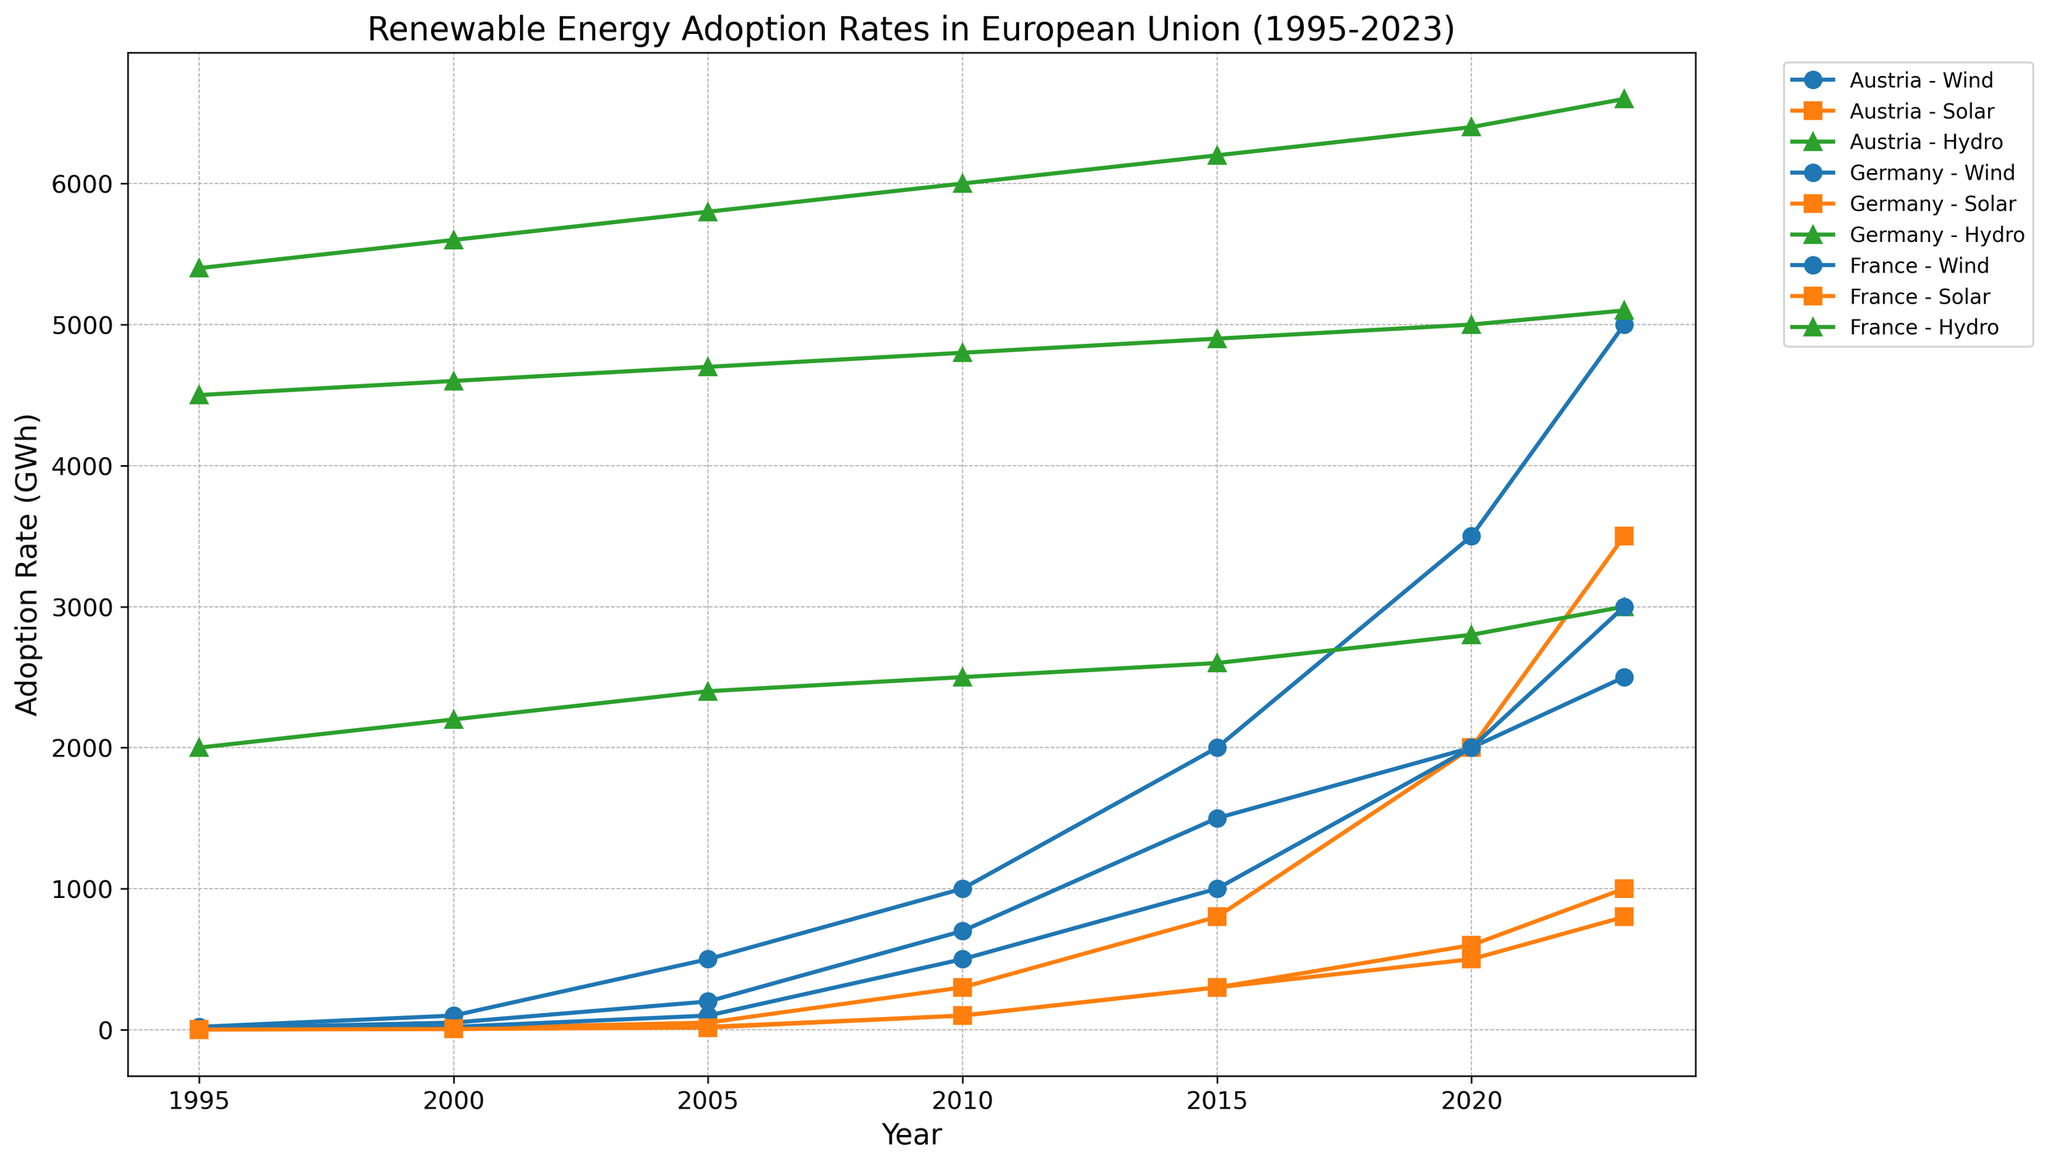What is the trend of wind energy adoption in Germany from 1995 to 2023? The trend of wind energy adoption in Germany is represented by a line with marker points. Observing the increasing trajectory, it starts at 20 GWh in 1995, rises to 100 GWh in 2000, continued growth is seen in the following years reaching 5000 GWh by 2023.
Answer: Increasing Which country had the highest solar energy adoption rate in the year 2020? By examining the markers associated with solar energy across all countries for the year 2020, the figure shows marked values (represented by squares) indicating the highest rate belonging to Germany with 2000 GWh.
Answer: Germany What is the difference in hydro energy adoption between Austria and France in 2023? The hydro energy adoption rates in 2023 are 6600 GWh for Austria and 5100 GWh for France. Calculating the difference between these two figures gives 6600 - 5100.
Answer: 1500 GWh How does the solar energy adoption rate of Austria compare to that of Germany in 2023? Comparing the adoption rates for 2023, Austria has an adoption rate marked at 800 GWh while Germany is marked at 3500 GWh. Germany's rate is significantly higher than Austria's.
Answer: Germany's rate is higher What is the average adoption rate of wind energy in France from 1995 to 2023? To find the average, we sum the adoption rates over the years for France (5, 20, 100, 500, 1000, 2000, 3000) which totals to 6625, and divide by the number of data points, which is 7 (i.e., 6625 / 7).
Answer: Approximately 946.43 GWh Which country has shown the most consistent growth in hydro energy adoption rates from 1995 to 2023? Observing the trajectory of hydro energy adoption rates plotted for each country, France has shown consistent incremental growth, improving gradually from 4500 GWh in 1995 to 5100 GWh in 2023.
Answer: France In the year 2010, which energy source had the highest adoption rate in Austria? Reviewing the adoption rates for Austria in 2010, hydro energy stands out with a marker indicating 6000 GWh, the highest among the sources (wind and solar).
Answer: Hydro What is the combined total wind energy adoption rate of Austria and Germany in 2023? Adding wind energy rates for Austria (2500 GWh) and Germany (5000 GWh) yields a total of 2500 + 5000.
Answer: 7500 GWh How does the adoption rate of solar energy in France change between 2000 and 2020? Observing the solar energy adoption in 2000 (5 GWh) and 2020 (600 GWh), we note an increase by subtracting the earlier rate from the later rate, showing a growth of 600 - 5.
Answer: 595 GWh Which energy source has the highest adoption rate overall in 2023 across all countries? Looking at the final year data points for 2023 for each energy source (wind, solar, hydro) across the countries, the hydro energy adoption rates are the highest, notably for Austria at 6600 GWh.
Answer: Hydro 